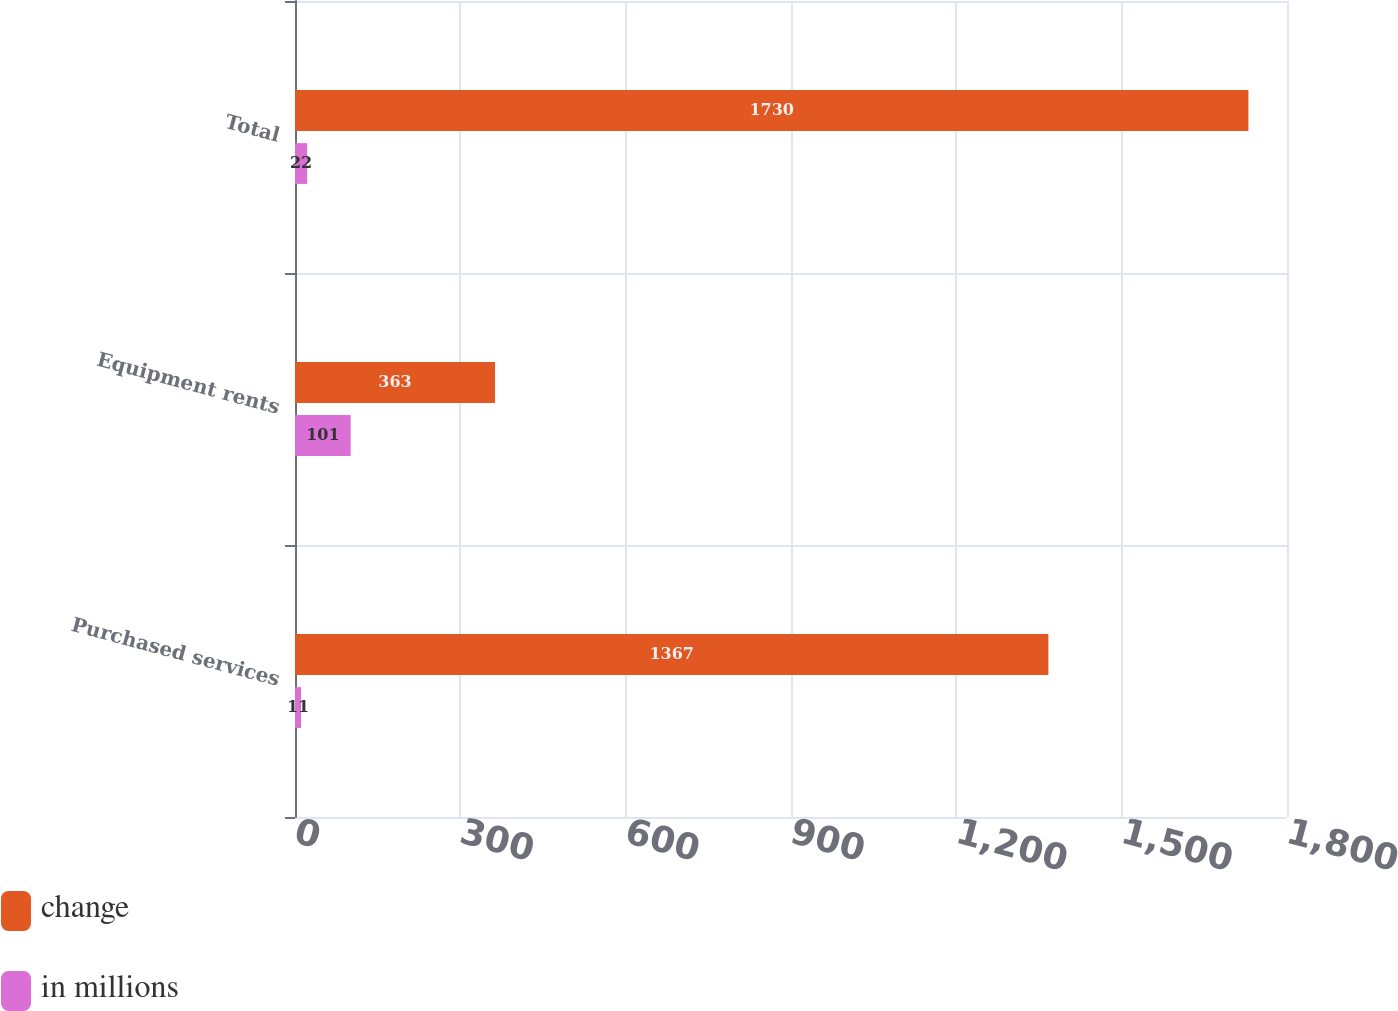<chart> <loc_0><loc_0><loc_500><loc_500><stacked_bar_chart><ecel><fcel>Purchased services<fcel>Equipment rents<fcel>Total<nl><fcel>change<fcel>1367<fcel>363<fcel>1730<nl><fcel>in millions<fcel>11<fcel>101<fcel>22<nl></chart> 